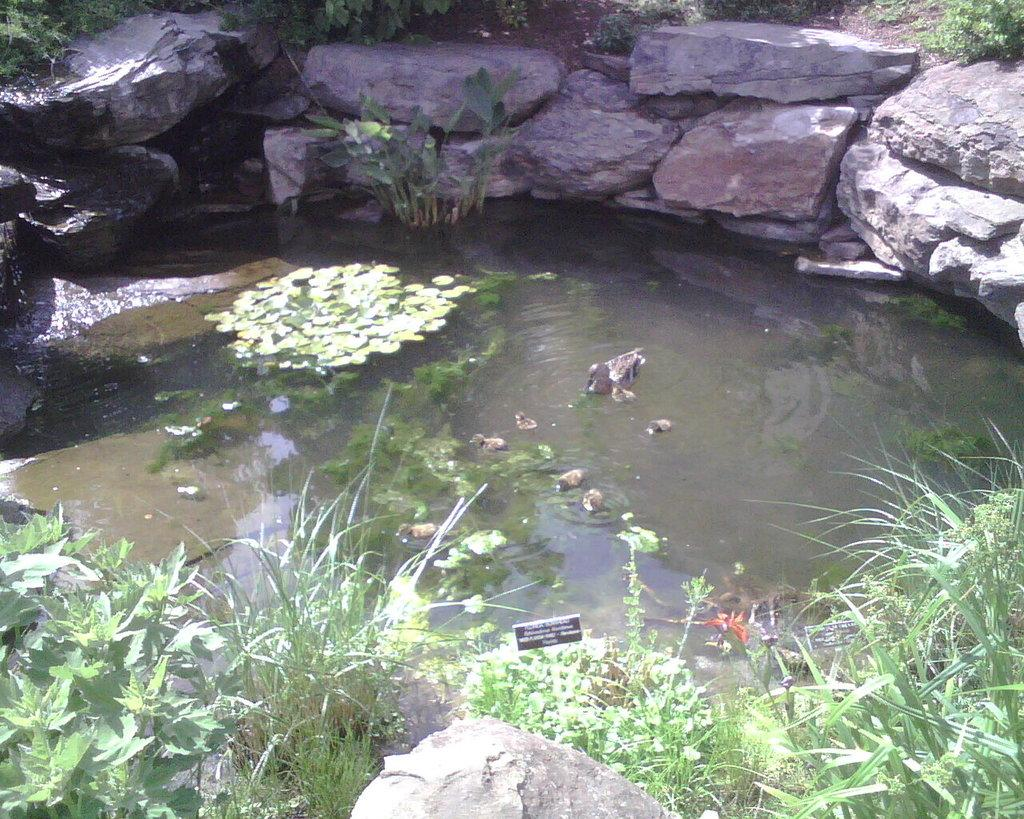What is the main feature in the center of the image? There is water in the center of the image. What can be observed in the water? The water contains algae. What surrounds the water in the image? There are rocks around the water. What type of vegetation is present in the image? There is greenery in the image. How does the coal contribute to the thrill in the image? There is no coal present in the image, so it cannot contribute to any thrill. 